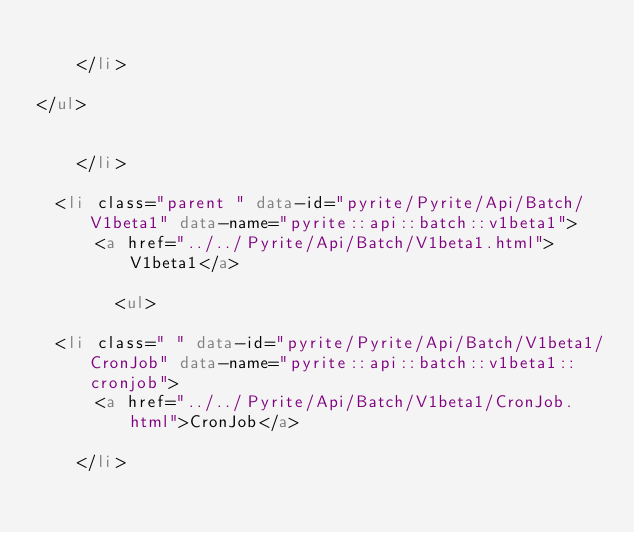Convert code to text. <code><loc_0><loc_0><loc_500><loc_500><_HTML_>      
    </li>
  
</ul>

      
    </li>
  
  <li class="parent " data-id="pyrite/Pyrite/Api/Batch/V1beta1" data-name="pyrite::api::batch::v1beta1">
      <a href="../../Pyrite/Api/Batch/V1beta1.html">V1beta1</a>
      
        <ul>
  
  <li class=" " data-id="pyrite/Pyrite/Api/Batch/V1beta1/CronJob" data-name="pyrite::api::batch::v1beta1::cronjob">
      <a href="../../Pyrite/Api/Batch/V1beta1/CronJob.html">CronJob</a>
      
    </li>
  </code> 